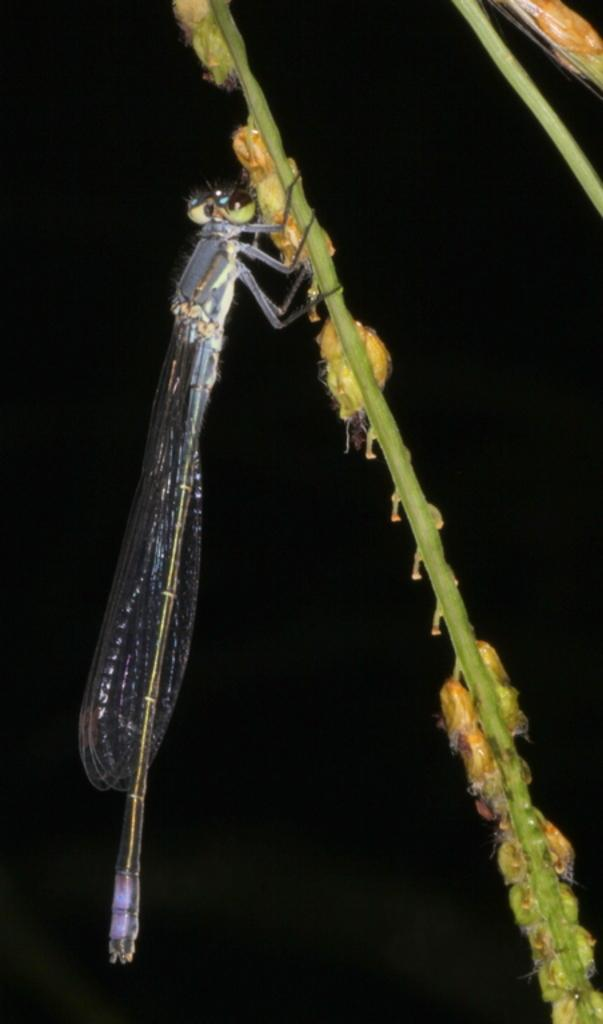What type of insect is in the image? There is a dragonfly in the image. Where is the dragonfly located? The dragonfly is on a stem. What else can be seen on the stem? There are grains on the stem. What is the color of the background in the image? The background of the image is dark. Reasoning: Let's think step by step by following the steps to produce the conversation. We start by identifying the main subject of the image, which is the dragonfly. Then, we describe its location and the presence of grains on the stem. Finally, we mention the color of the background, which is dark. We ensure that each question can be answered definitively with the information given and avoid yes/no questions. Absurd Question/Answer: What type of pets can be seen playing rhythm on a guitar in the image? There are no pets or guitars present in the image; it features a dragonfly on a stem with grains. 